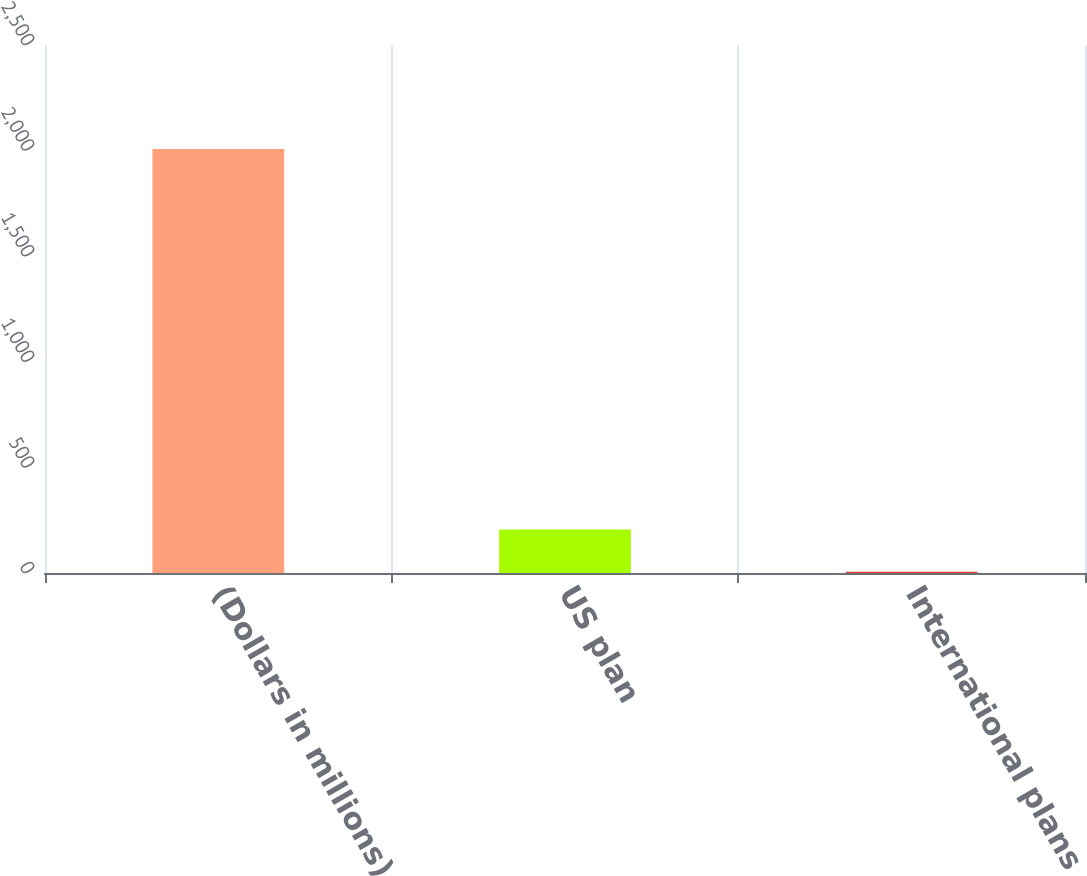Convert chart to OTSL. <chart><loc_0><loc_0><loc_500><loc_500><bar_chart><fcel>(Dollars in millions)<fcel>US plan<fcel>International plans<nl><fcel>2008<fcel>206.2<fcel>6<nl></chart> 